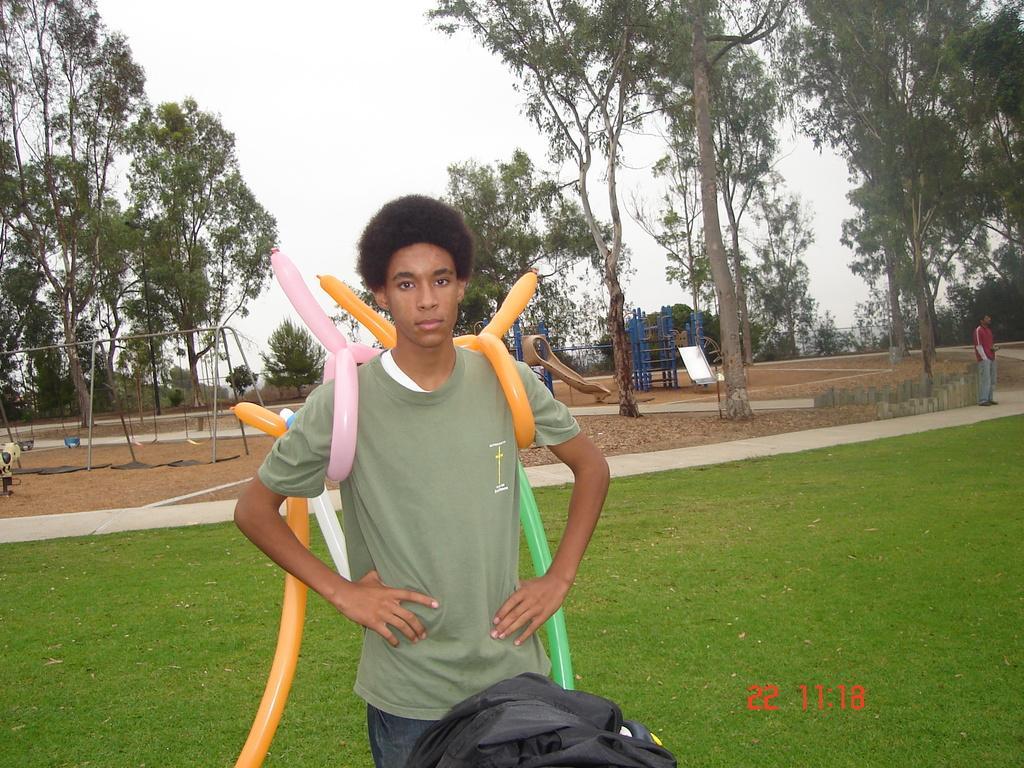Describe this image in one or two sentences. In this image we can see a boy standing on the grass. He is wearing a T-shirt and here we can see the balloons in different structure. Here we can see the bag at the bottom. Here we can see another man on the right side. In the background, we can see the children playing equipment and trees. 